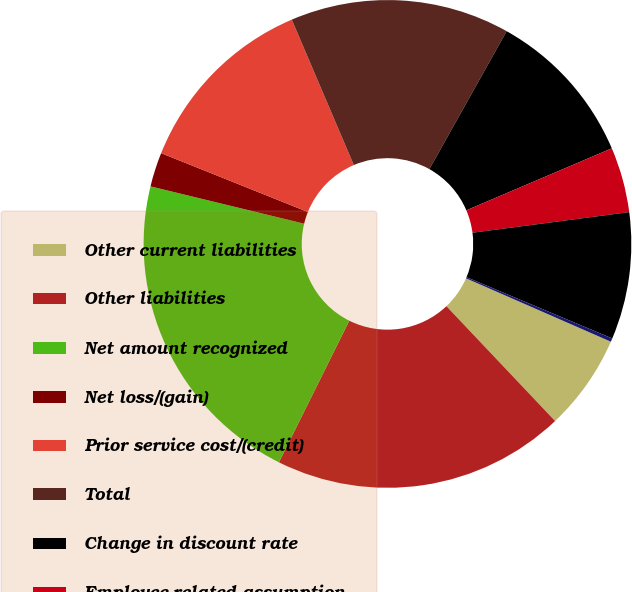Convert chart. <chart><loc_0><loc_0><loc_500><loc_500><pie_chart><fcel>Other current liabilities<fcel>Other liabilities<fcel>Net amount recognized<fcel>Net loss/(gain)<fcel>Prior service cost/(credit)<fcel>Total<fcel>Change in discount rate<fcel>Employee-related assumption<fcel>Liability-related experience<fcel>Actual asset return different<nl><fcel>6.37%<fcel>19.41%<fcel>21.45%<fcel>2.28%<fcel>12.51%<fcel>14.55%<fcel>10.46%<fcel>4.33%<fcel>8.42%<fcel>0.23%<nl></chart> 